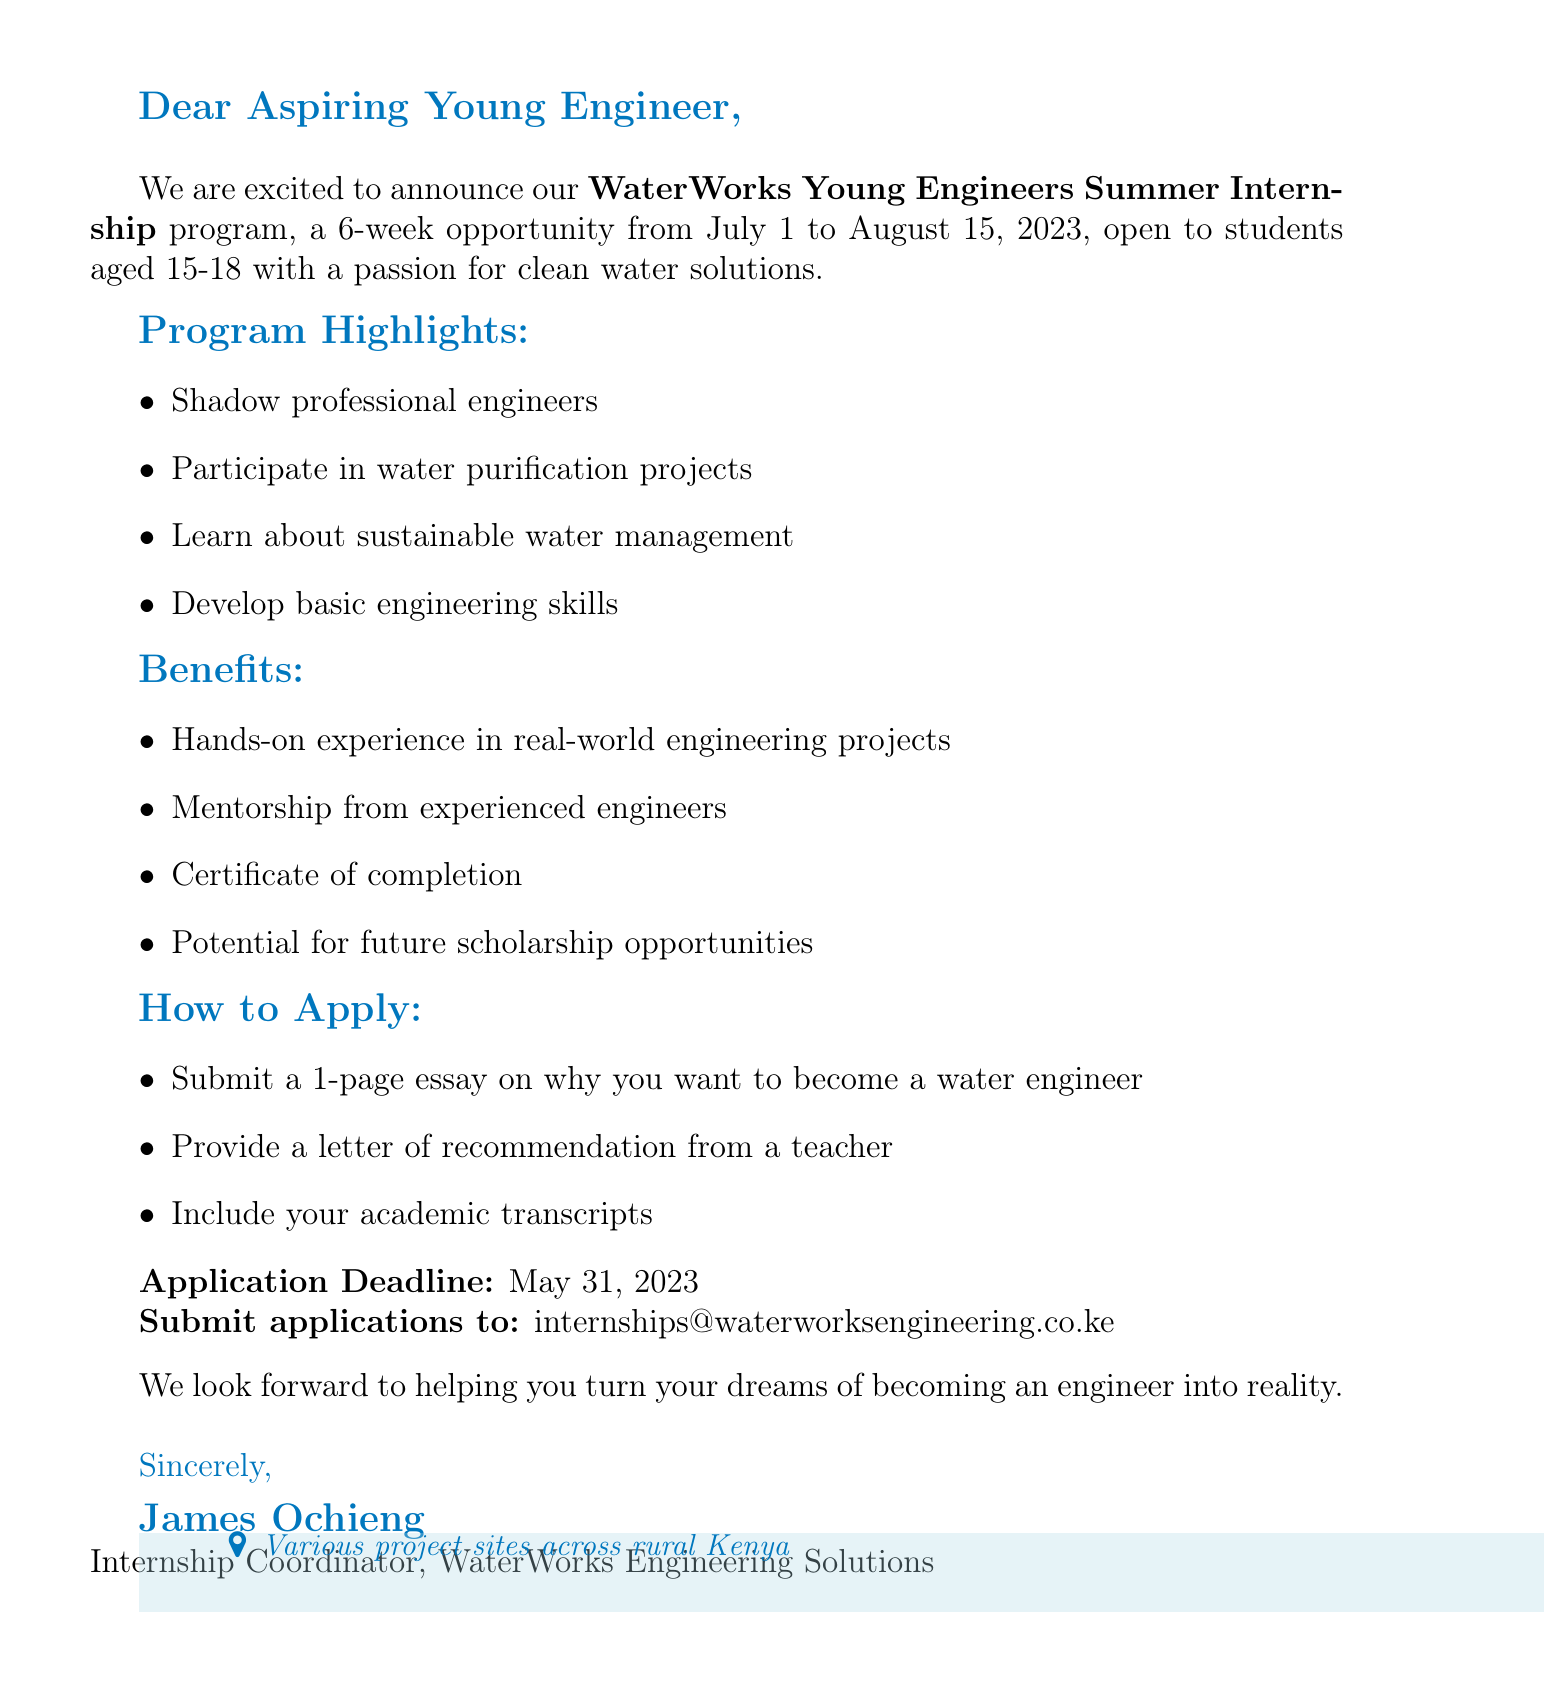What is the name of the internship program? The name of the internship program is explicitly mentioned in the document, which is "WaterWorks Young Engineers Summer Internship."
Answer: WaterWorks Young Engineers Summer Internship What is the duration of the program? The duration of the program is stated as "6 weeks (July 1 - August 15, 2023)."
Answer: 6 weeks (July 1 - August 15, 2023) Who is eligible to apply for the internship? Eligibility requirements for the program are outlined in the document as being "students aged 15-18 with a passion for clean water solutions."
Answer: Students aged 15-18 What are some activities participants will engage in? The document lists several activities, including shadowing engineers, participating in projects, etc. A specific activity mentioned is "Participating in water purification projects."
Answer: Participating in water purification projects What is one benefit of the internship? Benefits are detailed in the letter, and one of them is provided as "Hands-on experience in real-world engineering projects."
Answer: Hands-on experience in real-world engineering projects What is the application deadline? The application deadline is clearly stated in the letter as "May 31, 2023."
Answer: May 31, 2023 What is required to apply for the internship? The document specifies that applicants need to include an "essay on why you want to become a water engineer."
Answer: 1-page essay Where should applications be submitted? The document provides a specific email for submission, which is "internships@waterworksengineering.co.ke."
Answer: internships@waterworksengineering.co.ke Who is the internship coordinator? The closing section includes the coordinator’s name, which is "James Ochieng."
Answer: James Ochieng 